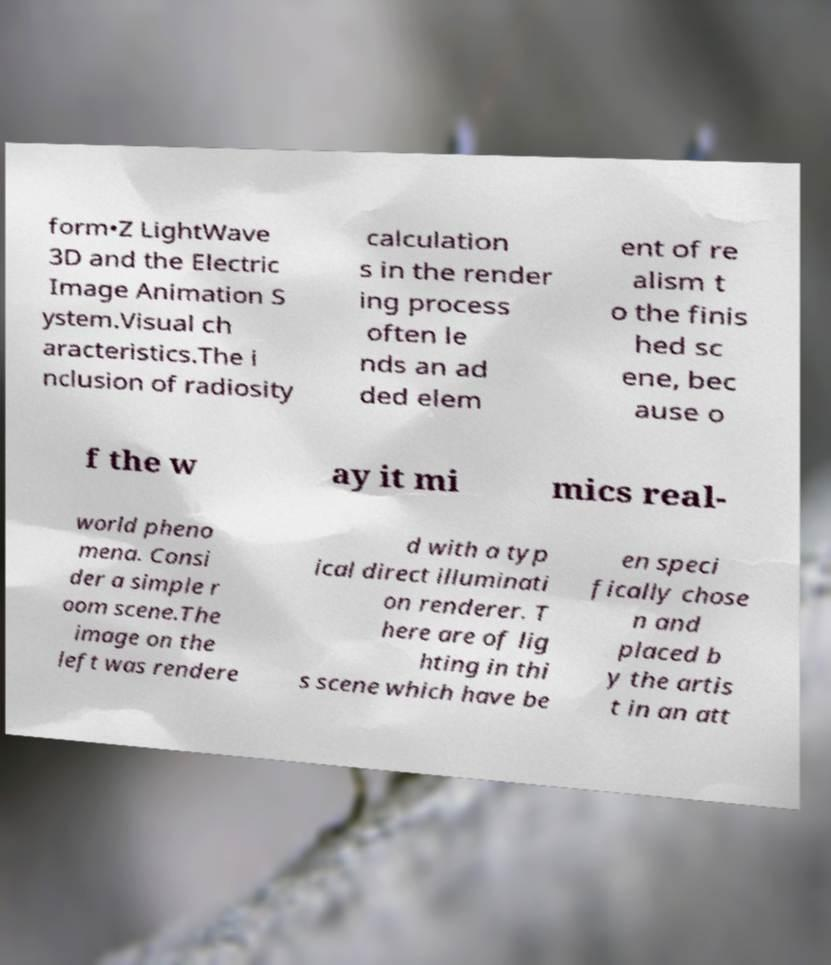I need the written content from this picture converted into text. Can you do that? form•Z LightWave 3D and the Electric Image Animation S ystem.Visual ch aracteristics.The i nclusion of radiosity calculation s in the render ing process often le nds an ad ded elem ent of re alism t o the finis hed sc ene, bec ause o f the w ay it mi mics real- world pheno mena. Consi der a simple r oom scene.The image on the left was rendere d with a typ ical direct illuminati on renderer. T here are of lig hting in thi s scene which have be en speci fically chose n and placed b y the artis t in an att 